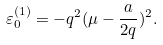Convert formula to latex. <formula><loc_0><loc_0><loc_500><loc_500>\varepsilon _ { 0 } ^ { ( 1 ) } = - q ^ { 2 } ( \mu - \frac { a } { 2 q } ) ^ { 2 } .</formula> 